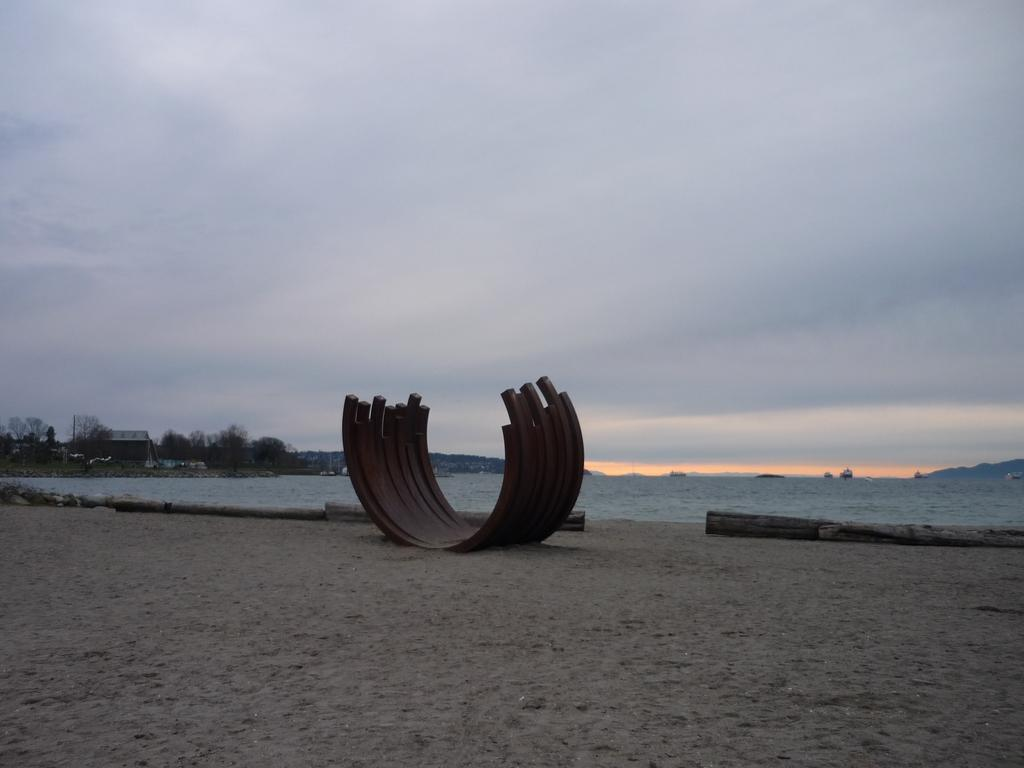What is the main subject of the image? There is a sculpture in the image. What can be seen on the seashore? There are wooden logs on the seashore. What type of natural environment is visible in the image? The seashore and sea are visible in the image. Are there any man-made structures in the image? Yes, there are buildings in the image. What other natural elements can be seen in the image? Trees and hills are present in the image. What is happening on the water? Ships are visible on the water. What is visible in the sky? The sky is visible in the image, and clouds are present. What type of yoke is being used by the farmer in the image? There is no farmer or yoke present in the image; it features a sculpture, seashore, sea, buildings, trees, hills, ships, sky, and clouds. 